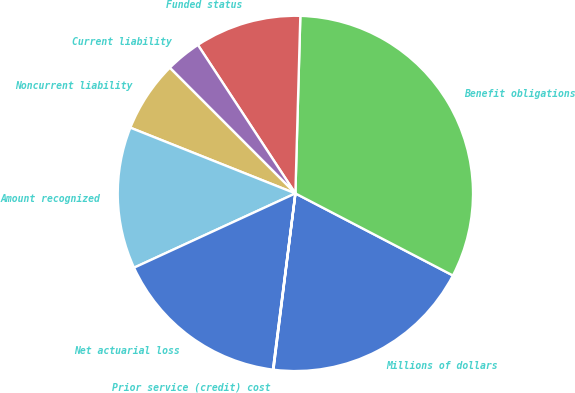<chart> <loc_0><loc_0><loc_500><loc_500><pie_chart><fcel>Millions of dollars<fcel>Benefit obligations<fcel>Funded status<fcel>Current liability<fcel>Noncurrent liability<fcel>Amount recognized<fcel>Net actuarial loss<fcel>Prior service (credit) cost<nl><fcel>19.33%<fcel>32.2%<fcel>9.69%<fcel>3.25%<fcel>6.47%<fcel>12.9%<fcel>16.12%<fcel>0.04%<nl></chart> 